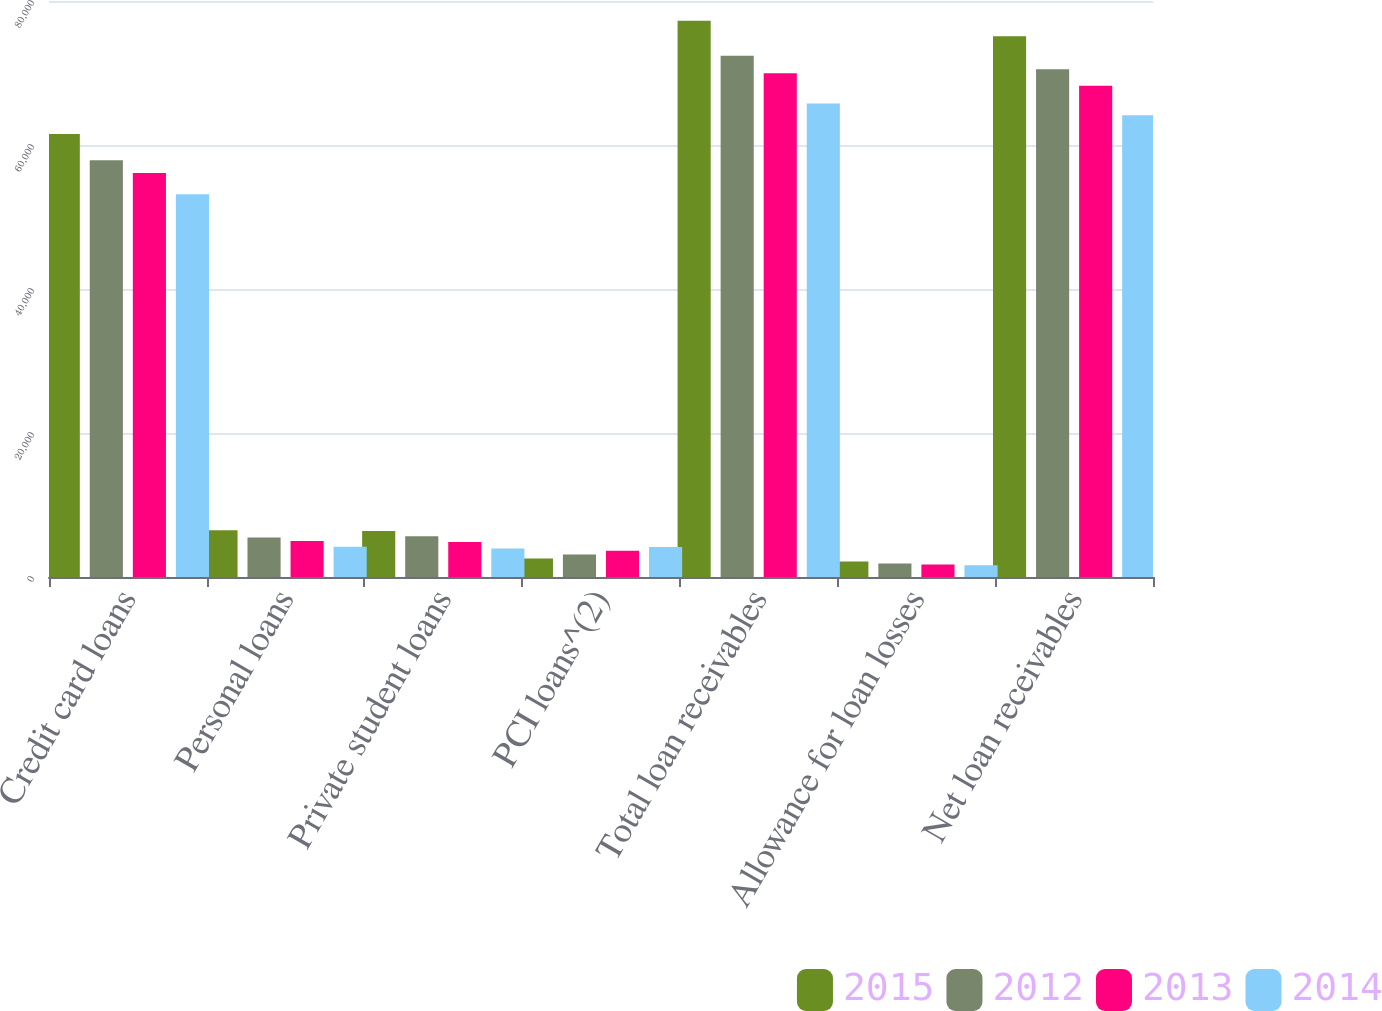Convert chart to OTSL. <chart><loc_0><loc_0><loc_500><loc_500><stacked_bar_chart><ecel><fcel>Credit card loans<fcel>Personal loans<fcel>Private student loans<fcel>PCI loans^(2)<fcel>Total loan receivables<fcel>Allowance for loan losses<fcel>Net loan receivables<nl><fcel>2015<fcel>61522<fcel>6481<fcel>6393<fcel>2584<fcel>77254<fcel>2167<fcel>75087<nl><fcel>2012<fcel>57896<fcel>5490<fcel>5647<fcel>3116<fcel>72385<fcel>1869<fcel>70516<nl><fcel>2013<fcel>56128<fcel>5007<fcel>4850<fcel>3660<fcel>69969<fcel>1746<fcel>68223<nl><fcel>2014<fcel>53150<fcel>4191<fcel>3969<fcel>4178<fcel>65771<fcel>1648<fcel>64123<nl></chart> 